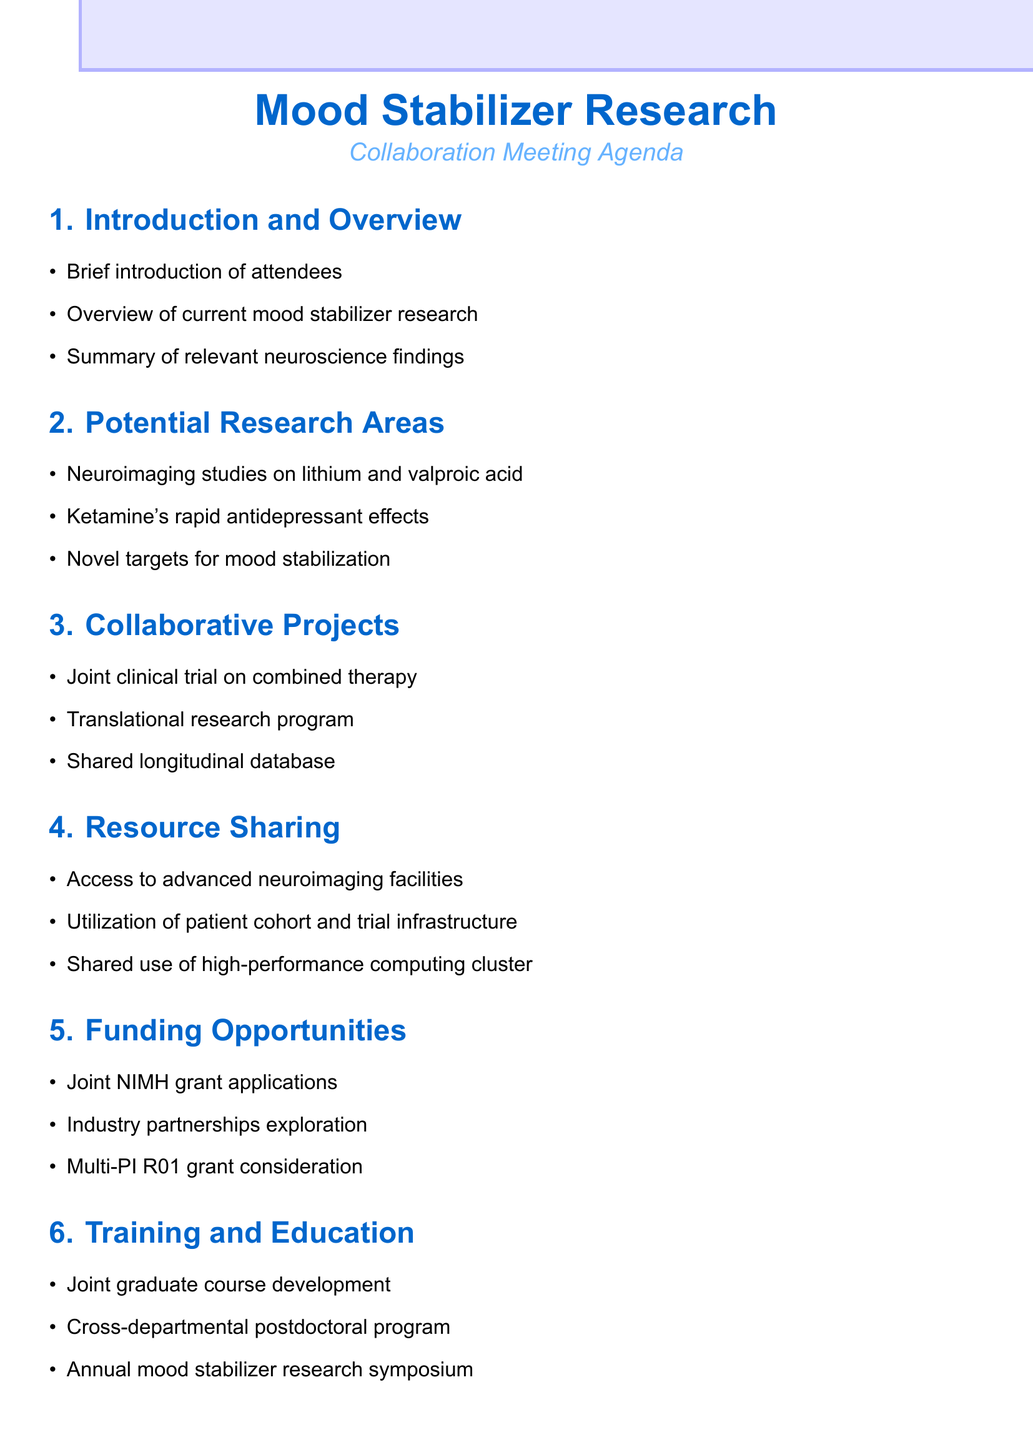What are the three neuroimaging studies mentioned? The agenda details three neuroimaging studies related to mood stabilizers: 1. Lithium and valproic acid effects on brain structure and function, 2. Ketamine's rapid antidepressant effects, 3. Novel targets for mood stabilization.
Answer: Lithium and valproic acid; Ketamine's rapid antidepressant effects; Novel targets for mood stabilization How many advanced neuroimaging facilities are mentioned? The document mentions access to one type of advanced neuroimaging facility, specifically the 7T MRI and MEG.
Answer: Two What is the first collaborative project listed? The first collaborative project outlined in the agenda is a joint clinical trial on the efficacy of combined psychotherapy and pharmacological treatment for bipolar disorder.
Answer: Joint clinical trial on the efficacy of combined psychotherapy and pharmacological treatment for bipolar disorder What potential funding source is mentioned? The agenda discusses potential joint grant applications to the National Institute of Mental Health (NIMH) as a funding opportunity.
Answer: National Institute of Mental Health (NIMH) What is the timeline for setting milestones? The milestones will be set for the next 6, 12, and 24 months as stated in the document's timeline section.
Answer: 6, 12, and 24 months What type of joint graduate course is proposed? The proposed joint graduate course will focus on the neurobiology of mood disorders, according to the training and education section.
Answer: Neurobiology of mood disorders 